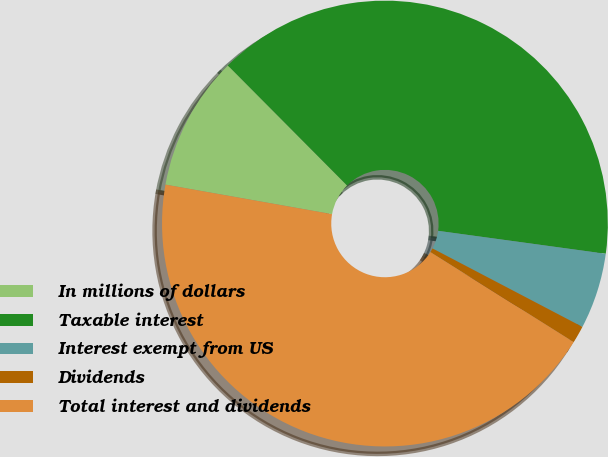Convert chart to OTSL. <chart><loc_0><loc_0><loc_500><loc_500><pie_chart><fcel>In millions of dollars<fcel>Taxable interest<fcel>Interest exempt from US<fcel>Dividends<fcel>Total interest and dividends<nl><fcel>9.76%<fcel>39.61%<fcel>5.51%<fcel>1.25%<fcel>43.87%<nl></chart> 